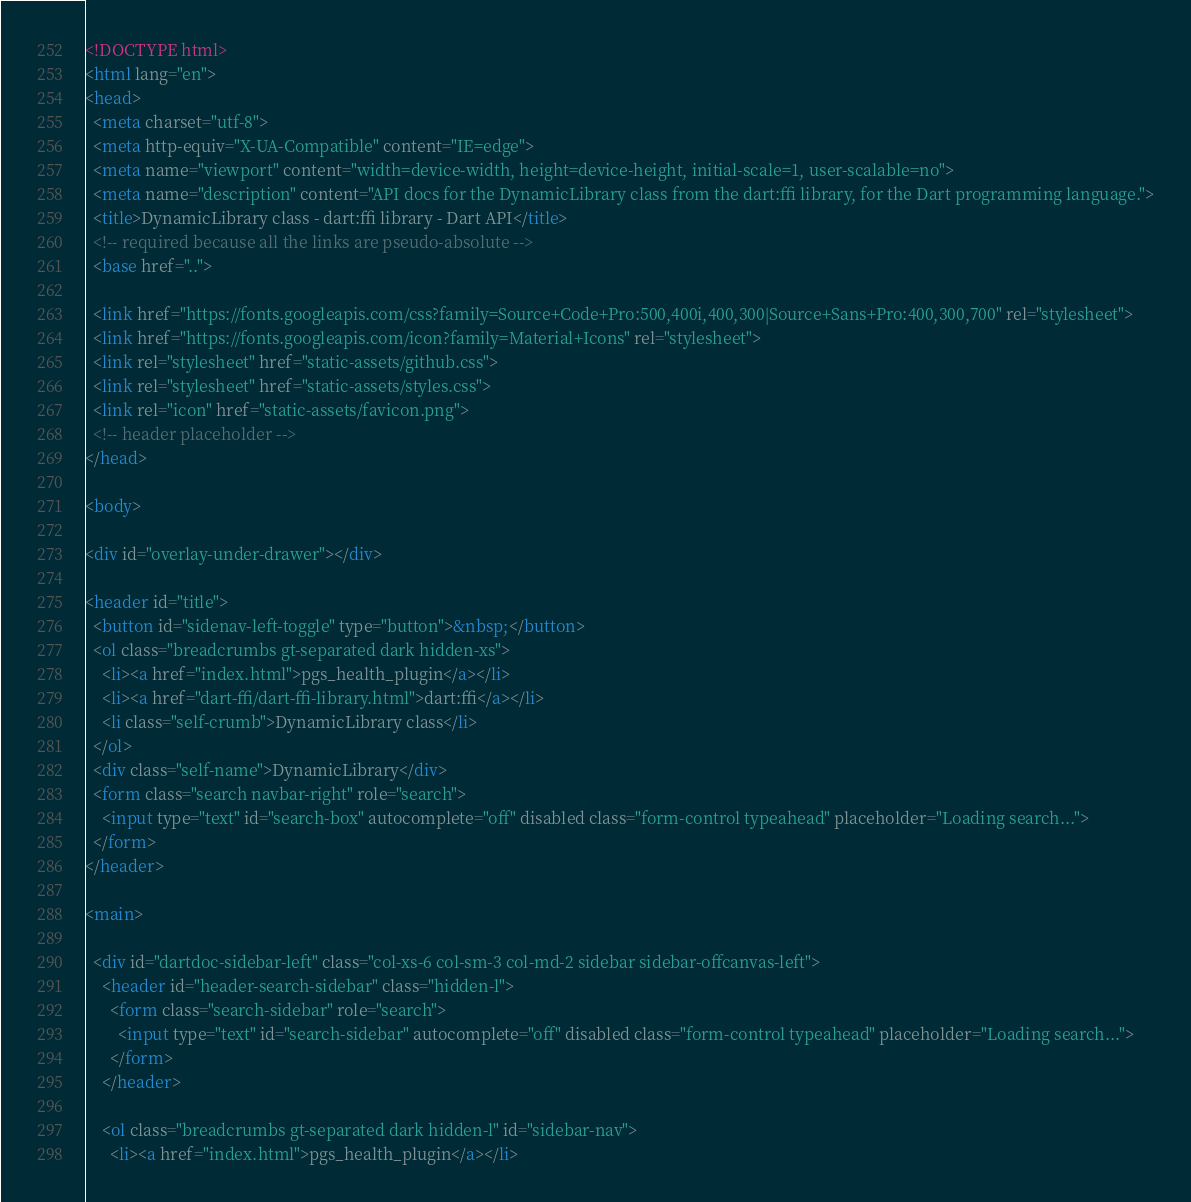<code> <loc_0><loc_0><loc_500><loc_500><_HTML_><!DOCTYPE html>
<html lang="en">
<head>
  <meta charset="utf-8">
  <meta http-equiv="X-UA-Compatible" content="IE=edge">
  <meta name="viewport" content="width=device-width, height=device-height, initial-scale=1, user-scalable=no">
  <meta name="description" content="API docs for the DynamicLibrary class from the dart:ffi library, for the Dart programming language.">
  <title>DynamicLibrary class - dart:ffi library - Dart API</title>
  <!-- required because all the links are pseudo-absolute -->
  <base href="..">

  <link href="https://fonts.googleapis.com/css?family=Source+Code+Pro:500,400i,400,300|Source+Sans+Pro:400,300,700" rel="stylesheet">
  <link href="https://fonts.googleapis.com/icon?family=Material+Icons" rel="stylesheet">
  <link rel="stylesheet" href="static-assets/github.css">
  <link rel="stylesheet" href="static-assets/styles.css">
  <link rel="icon" href="static-assets/favicon.png">
  <!-- header placeholder -->
</head>

<body>

<div id="overlay-under-drawer"></div>

<header id="title">
  <button id="sidenav-left-toggle" type="button">&nbsp;</button>
  <ol class="breadcrumbs gt-separated dark hidden-xs">
    <li><a href="index.html">pgs_health_plugin</a></li>
    <li><a href="dart-ffi/dart-ffi-library.html">dart:ffi</a></li>
    <li class="self-crumb">DynamicLibrary class</li>
  </ol>
  <div class="self-name">DynamicLibrary</div>
  <form class="search navbar-right" role="search">
    <input type="text" id="search-box" autocomplete="off" disabled class="form-control typeahead" placeholder="Loading search...">
  </form>
</header>

<main>

  <div id="dartdoc-sidebar-left" class="col-xs-6 col-sm-3 col-md-2 sidebar sidebar-offcanvas-left">
    <header id="header-search-sidebar" class="hidden-l">
      <form class="search-sidebar" role="search">
        <input type="text" id="search-sidebar" autocomplete="off" disabled class="form-control typeahead" placeholder="Loading search...">
      </form>
    </header>
    
    <ol class="breadcrumbs gt-separated dark hidden-l" id="sidebar-nav">
      <li><a href="index.html">pgs_health_plugin</a></li></code> 